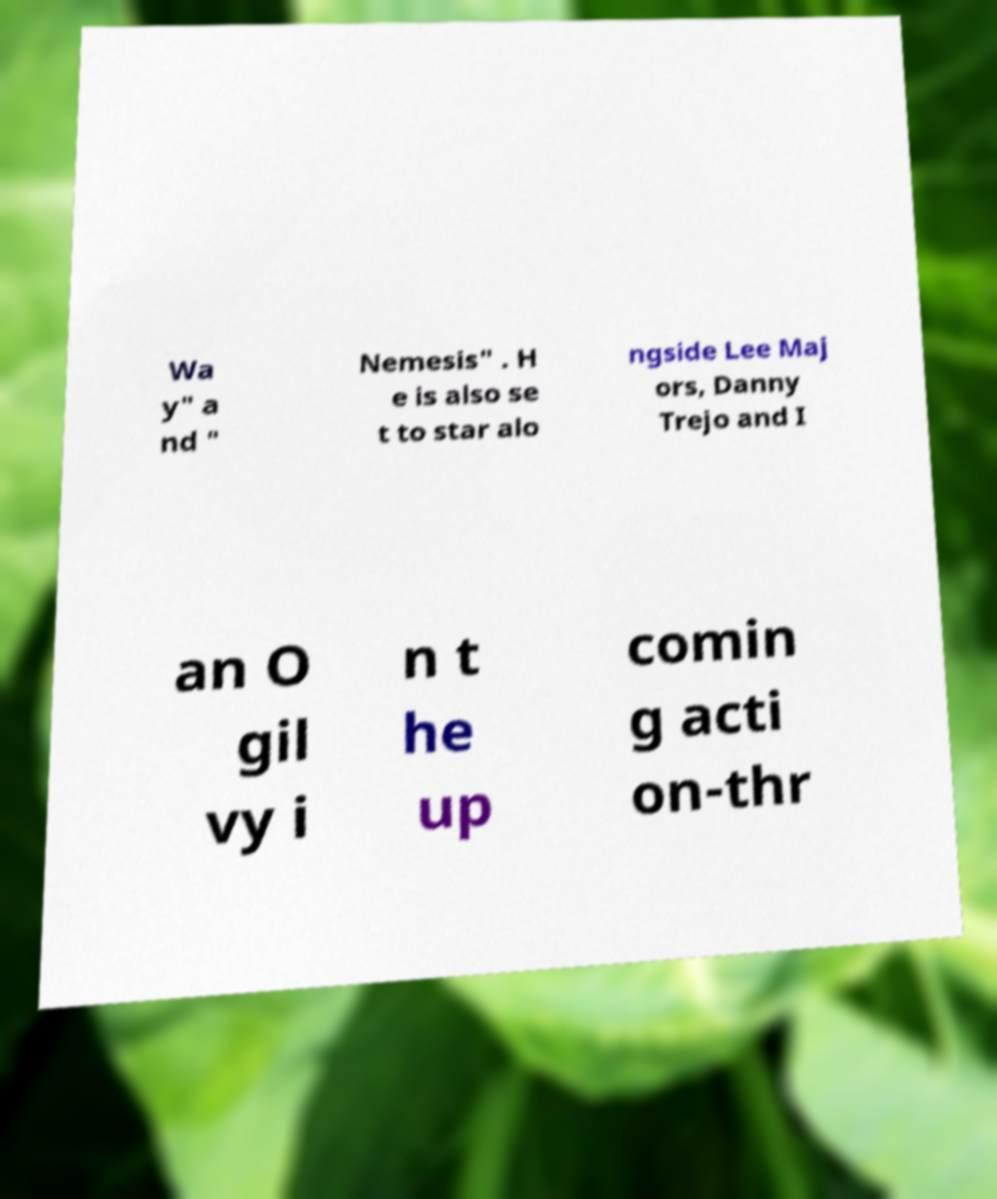Please read and relay the text visible in this image. What does it say? Wa y" a nd " Nemesis" . H e is also se t to star alo ngside Lee Maj ors, Danny Trejo and I an O gil vy i n t he up comin g acti on-thr 